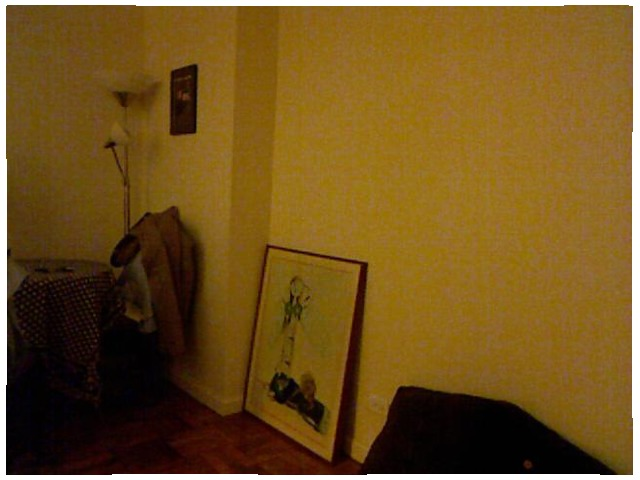<image>
Can you confirm if the photo frame is on the floor? Yes. Looking at the image, I can see the photo frame is positioned on top of the floor, with the floor providing support. Is the lamp next to the wall? Yes. The lamp is positioned adjacent to the wall, located nearby in the same general area. 